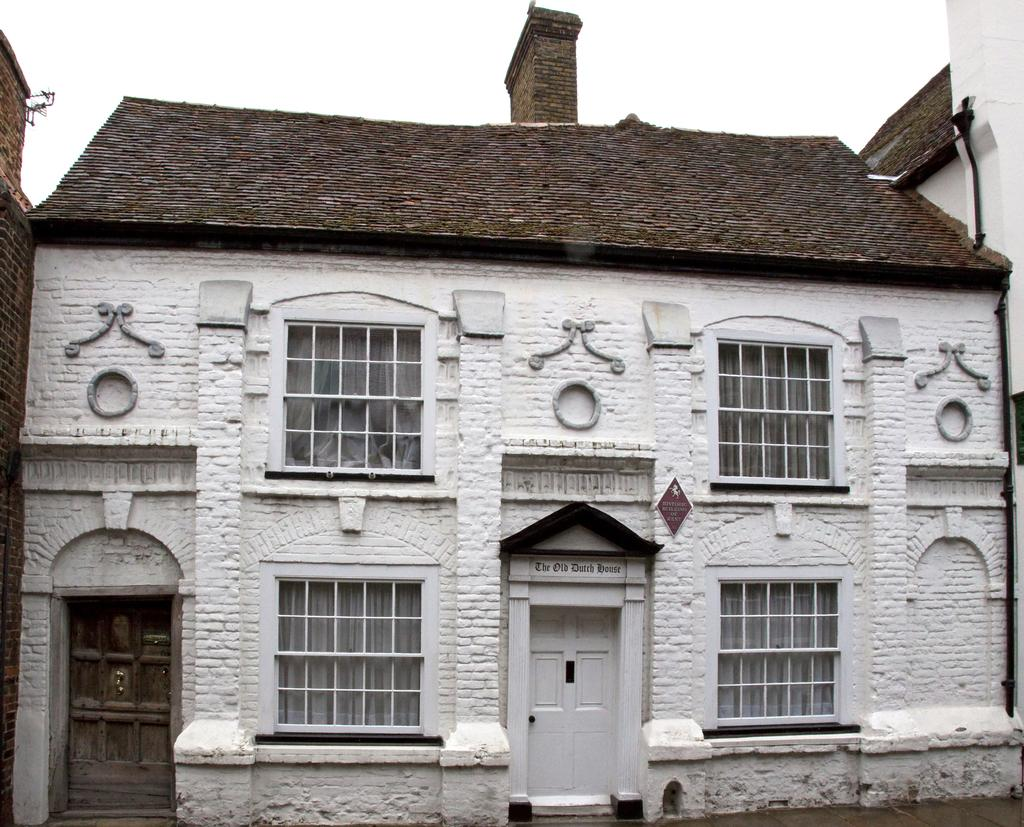What is the primary color of the house in the image? The house in the image is white in color. What is the color of the roof on the house? The roof of the house is brown in color. What type of material covers the roof of the house? There are roofing tiles on the house. What feature can be seen on the roof of the house? There is a chimney on the roof of the house. What type of needle is used to sew the party decorations in the image? There is no needle or party decorations present in the image; it features a house with a brown roof and roofing tiles. 